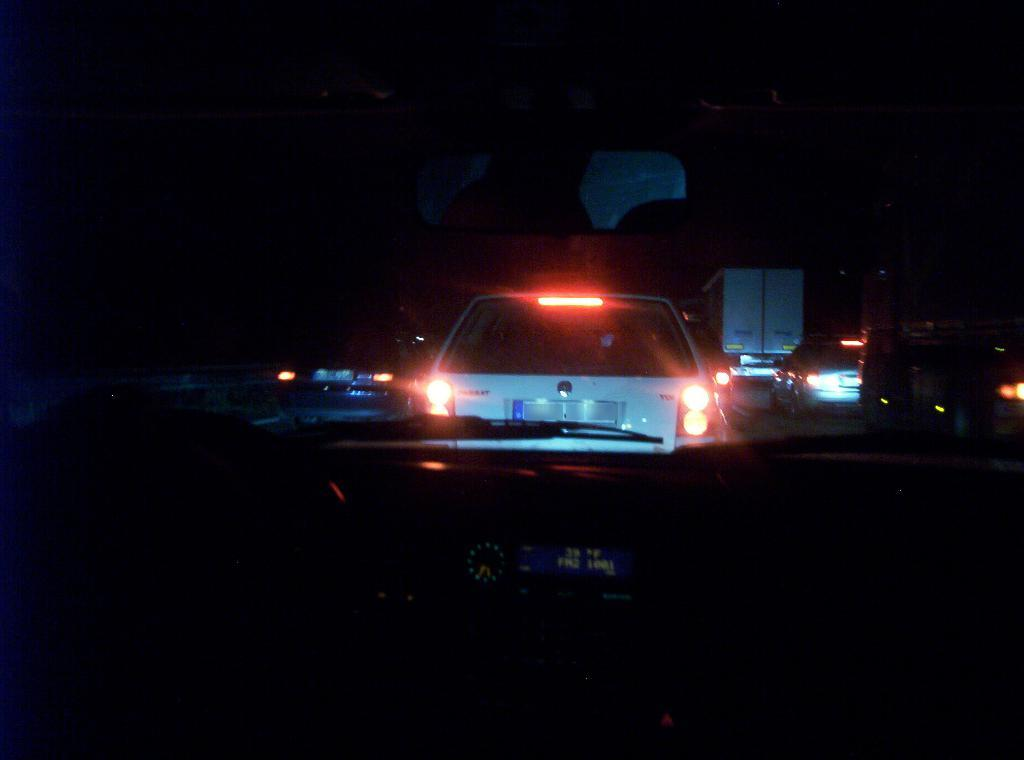What types of vehicles can be seen on the road in the image? There are cars and trucks on the road in the image. What part of a vehicle is visible in the image? A windshield is visible in the image. What part of a vehicle's interior is present in the image? A dashboard is present in the image. What type of wound can be seen on the son's arm in the image? There is no son or wound present in the image; it only features cars, trucks, a windshield, and a dashboard. 